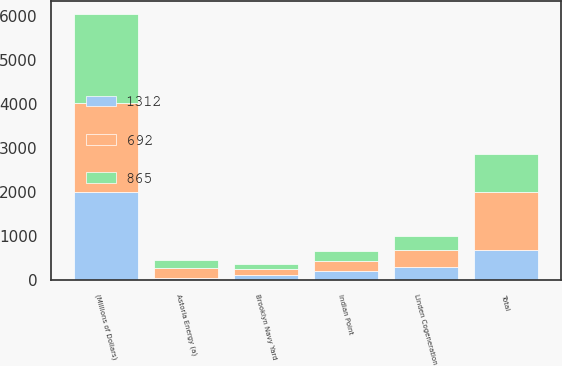Convert chart to OTSL. <chart><loc_0><loc_0><loc_500><loc_500><stacked_bar_chart><ecel><fcel>(Millions of Dollars)<fcel>Linden Cogeneration<fcel>Indian Point<fcel>Astoria Energy (a)<fcel>Brooklyn Navy Yard<fcel>Total<nl><fcel>1312<fcel>2016<fcel>304<fcel>203<fcel>50<fcel>119<fcel>692<nl><fcel>865<fcel>2015<fcel>323<fcel>226<fcel>178<fcel>113<fcel>865<nl><fcel>692<fcel>2014<fcel>381<fcel>247<fcel>230<fcel>133<fcel>1312<nl></chart> 